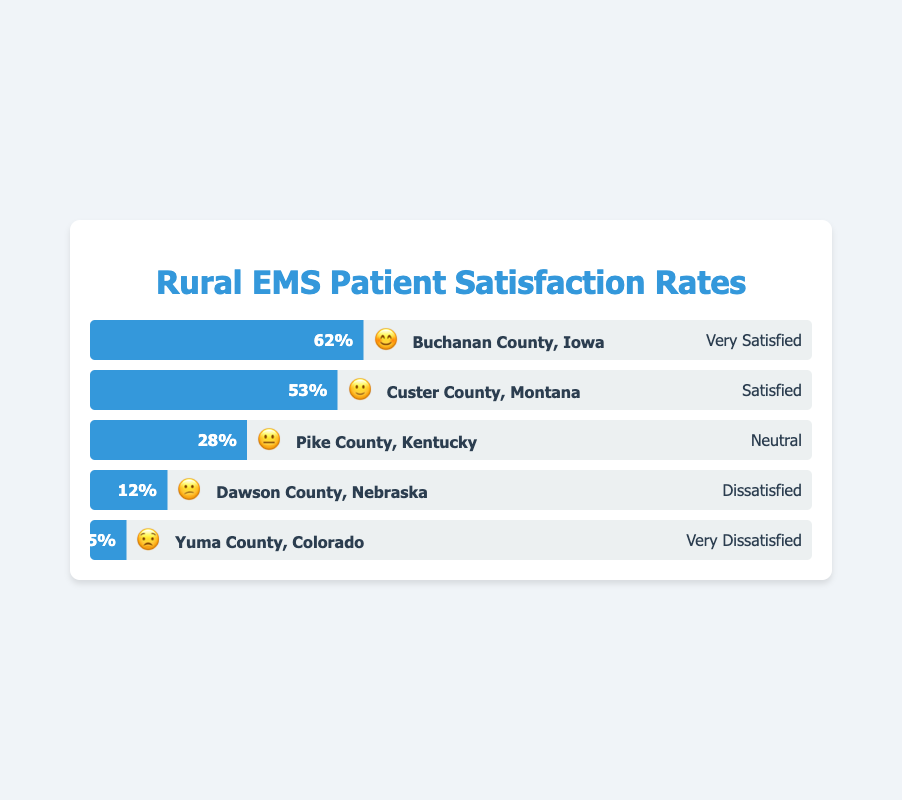What is the percentage of patients who were Very Satisfied in Buchanan County, Iowa? The information can be directly obtained from the bar with the emoji 😊 for Buchanan County, Iowa. It is shown as 62%.
Answer: 62% Which county has the lowest patient satisfaction rate, and what is the percentage? Locate the bar with the smallest filled width and the 😟 emoji, which corresponds to Yuma County, Colorado. The percentage is shown as 5%.
Answer: Yuma County, Colorado, 5% How does the satisfaction rate of Custer County, Montana compare to Pike County, Kentucky? Compare the two bars' width and corresponding percentages. Custer County, Montana (🙂) has a 53% satisfaction rate, while Pike County, Kentucky (😐) has a 28% satisfaction rate, making Custer County higher.
Answer: Custer County, Montana is higher What is the average satisfaction rate among all the counties shown? Sum the satisfaction percentages of the five counties and divide by the number of counties. The percentages are: 62%, 53%, 28%, 12%, and 5%. (62 + 53 + 28 + 12 + 5) / 5 = 160 / 5 = 32%
Answer: 32% Which county has the highest number of Dissatisfied patients, and what is the percentage? Look for the county with the 😕 emoji. Dawson County, Nebraska shows a 12% dissatisfaction rate.
Answer: Dawson County, Nebraska, 12% What is the combined satisfaction rate of counties with “Satisfied” and “Very Satisfied” ratings? Add the percentages of Buchanan County, Iowa (Very Satisfied, 62%) and Custer County, Montana (Satisfied, 53%). 62% + 53% = 115%
Answer: 115% What percentage of patients were either Neutral or Dissatisfied in Pike County, Kentucky? Locate the percentages for Neutral (28%) and Dissatisfied (12%) patients. 28% + 12% = 40%. Note that here "Neutral" is considered along with "Dissatisfied."
Answer: 40% How does the patient satisfaction in Buchanan County, Iowa (Very Satisfied) compare to the combined percentage of Dissatisfied and Very Dissatisfied patients in all the other counties? Buchanan County, Iowa has a 62% Very Satisfied rate. The combined percentage of Dissatisfied and Very Dissatisfied in the other counties are: Dawson County (12%) and Yuma County (5%). 12% + 5% = 17%. Buchanan County's satisfaction rate is much higher.
Answer: Much higher Which two counties account for the highest and lowest patient satisfaction rates respectively? Identify the counties with the highest and lowest filled bars. Buchanan County, Iowa (😊) has the highest at 62%, and Yuma County, Colorado (😟) has the lowest at 5%.
Answer: Buchanan County, Iowa (highest), Yuma County, Colorado (lowest) What is the difference in the satisfaction rates between the county with the highest and the county with the lowest satisfaction? The percentage for Buchanan County, Iowa is 62% and Yuma County, Colorado is 5%. 62% - 5% = 57%.
Answer: 57% 